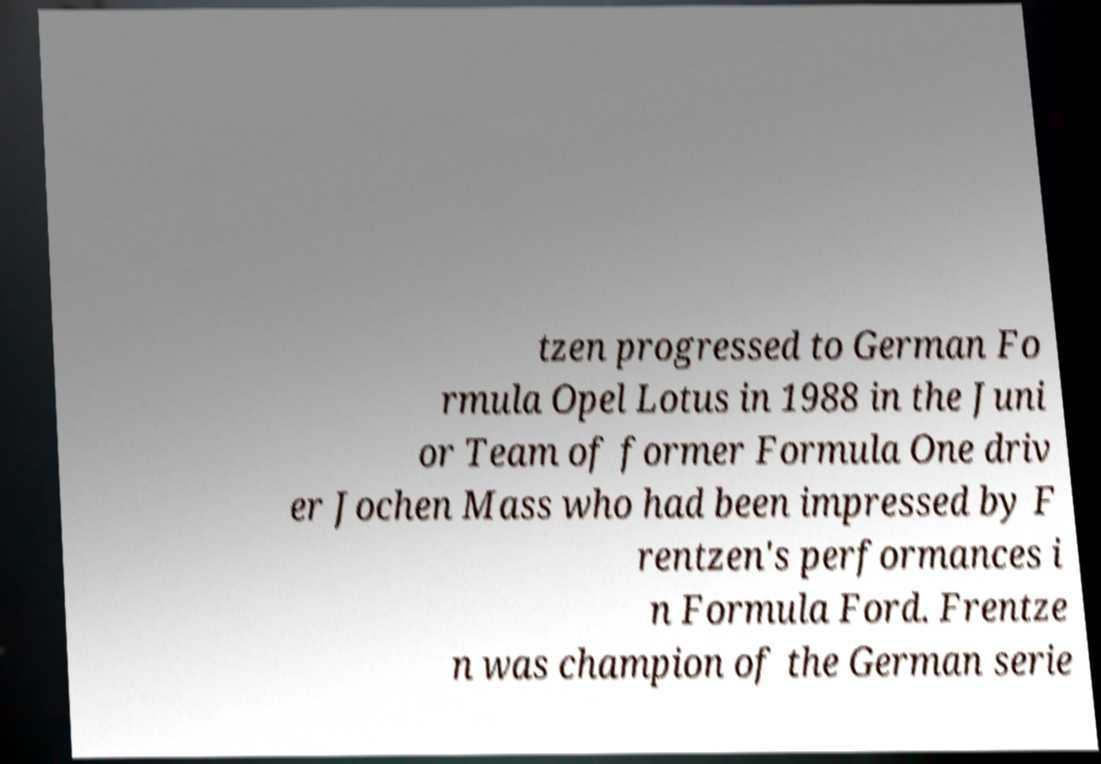Can you accurately transcribe the text from the provided image for me? tzen progressed to German Fo rmula Opel Lotus in 1988 in the Juni or Team of former Formula One driv er Jochen Mass who had been impressed by F rentzen's performances i n Formula Ford. Frentze n was champion of the German serie 